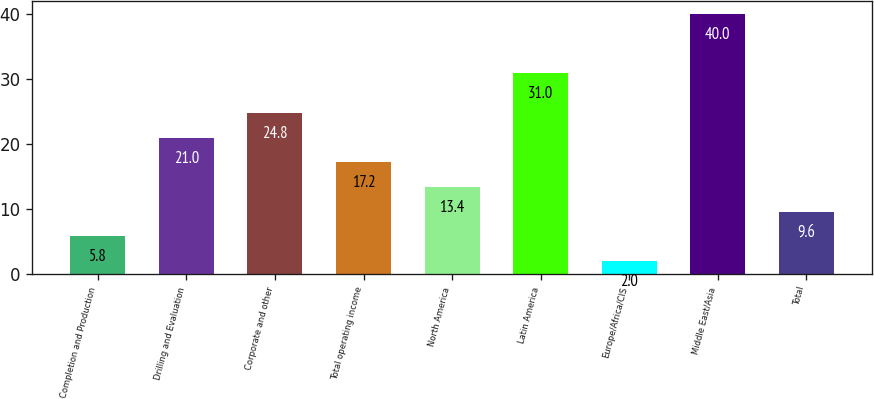Convert chart. <chart><loc_0><loc_0><loc_500><loc_500><bar_chart><fcel>Completion and Production<fcel>Drilling and Evaluation<fcel>Corporate and other<fcel>Total operating income<fcel>North America<fcel>Latin America<fcel>Europe/Africa/CIS<fcel>Middle East/Asia<fcel>Total<nl><fcel>5.8<fcel>21<fcel>24.8<fcel>17.2<fcel>13.4<fcel>31<fcel>2<fcel>40<fcel>9.6<nl></chart> 